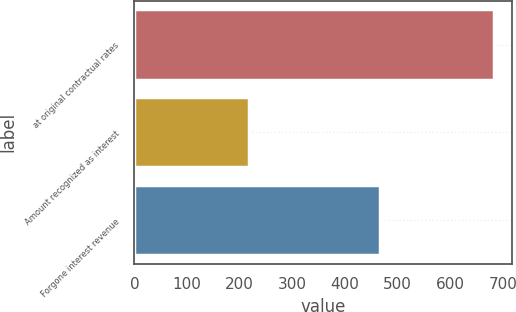Convert chart to OTSL. <chart><loc_0><loc_0><loc_500><loc_500><bar_chart><fcel>at original contractual rates<fcel>Amount recognized as interest<fcel>Forgone interest revenue<nl><fcel>683<fcel>217<fcel>466<nl></chart> 